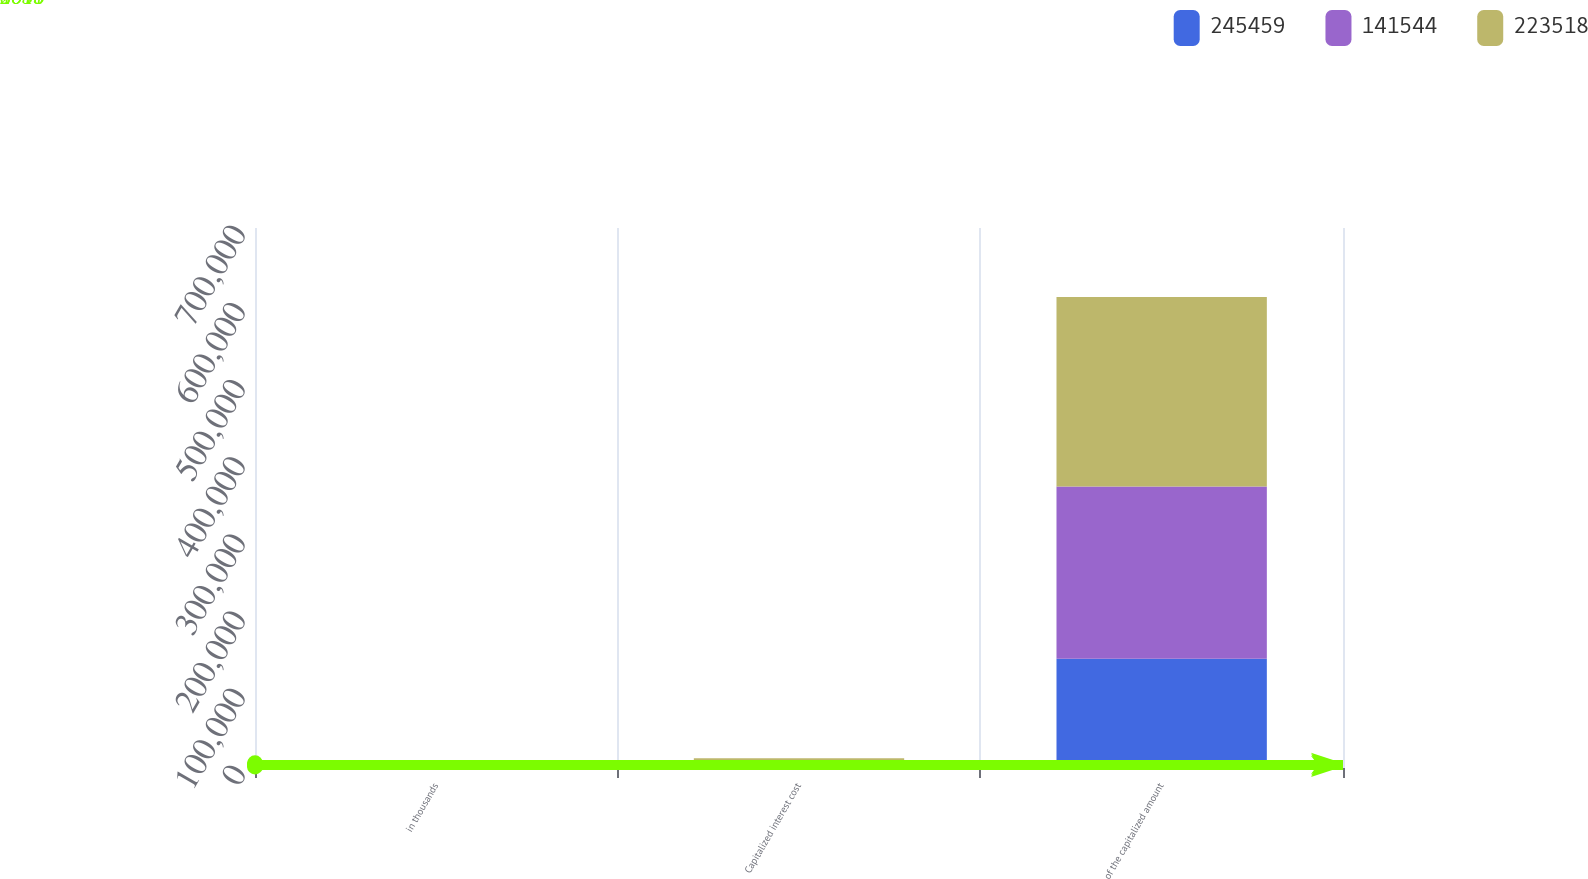Convert chart to OTSL. <chart><loc_0><loc_0><loc_500><loc_500><stacked_bar_chart><ecel><fcel>in thousands<fcel>Capitalized interest cost<fcel>of the capitalized amount<nl><fcel>245459<fcel>2016<fcel>7468<fcel>141544<nl><fcel>141544<fcel>2015<fcel>2930<fcel>223518<nl><fcel>223518<fcel>2014<fcel>2092<fcel>245459<nl></chart> 